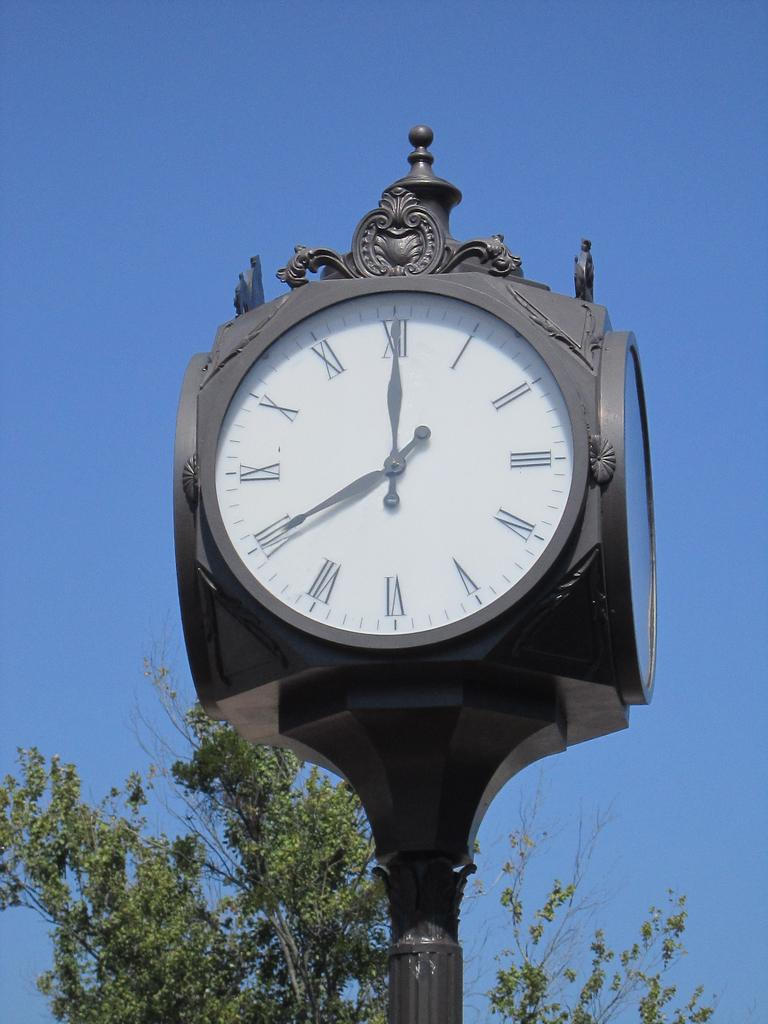<image>
Summarize the visual content of the image. a street clock that says seven o'clock on it 